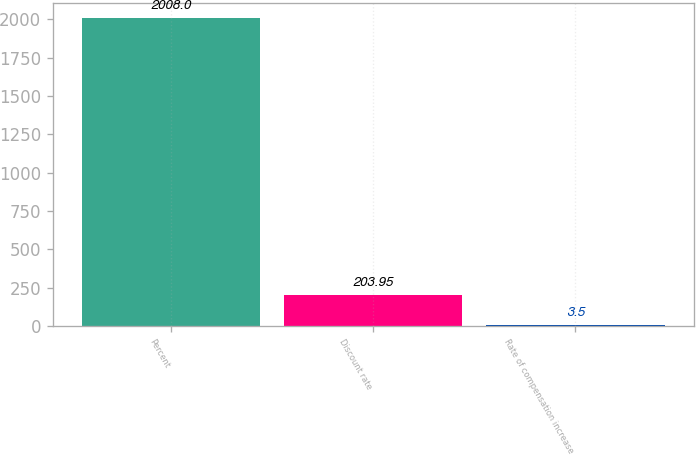Convert chart to OTSL. <chart><loc_0><loc_0><loc_500><loc_500><bar_chart><fcel>Percent<fcel>Discount rate<fcel>Rate of compensation increase<nl><fcel>2008<fcel>203.95<fcel>3.5<nl></chart> 